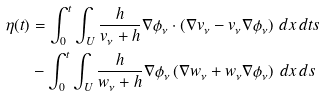<formula> <loc_0><loc_0><loc_500><loc_500>\eta ( t ) & = \int _ { 0 } ^ { t } \int _ { U } \frac { h } { v _ { \nu } + h } \nabla \phi _ { \nu } \cdot \left ( \nabla v _ { \nu } - v _ { \nu } \nabla \phi _ { \nu } \right ) \, d x \, d t s \\ & - \int _ { 0 } ^ { t } \int _ { U } \frac { h } { w _ { \nu } + h } \nabla \phi _ { \nu } \left ( \nabla w _ { \nu } + w _ { \nu } \nabla \phi _ { \nu } \right ) \, d x \, d s</formula> 